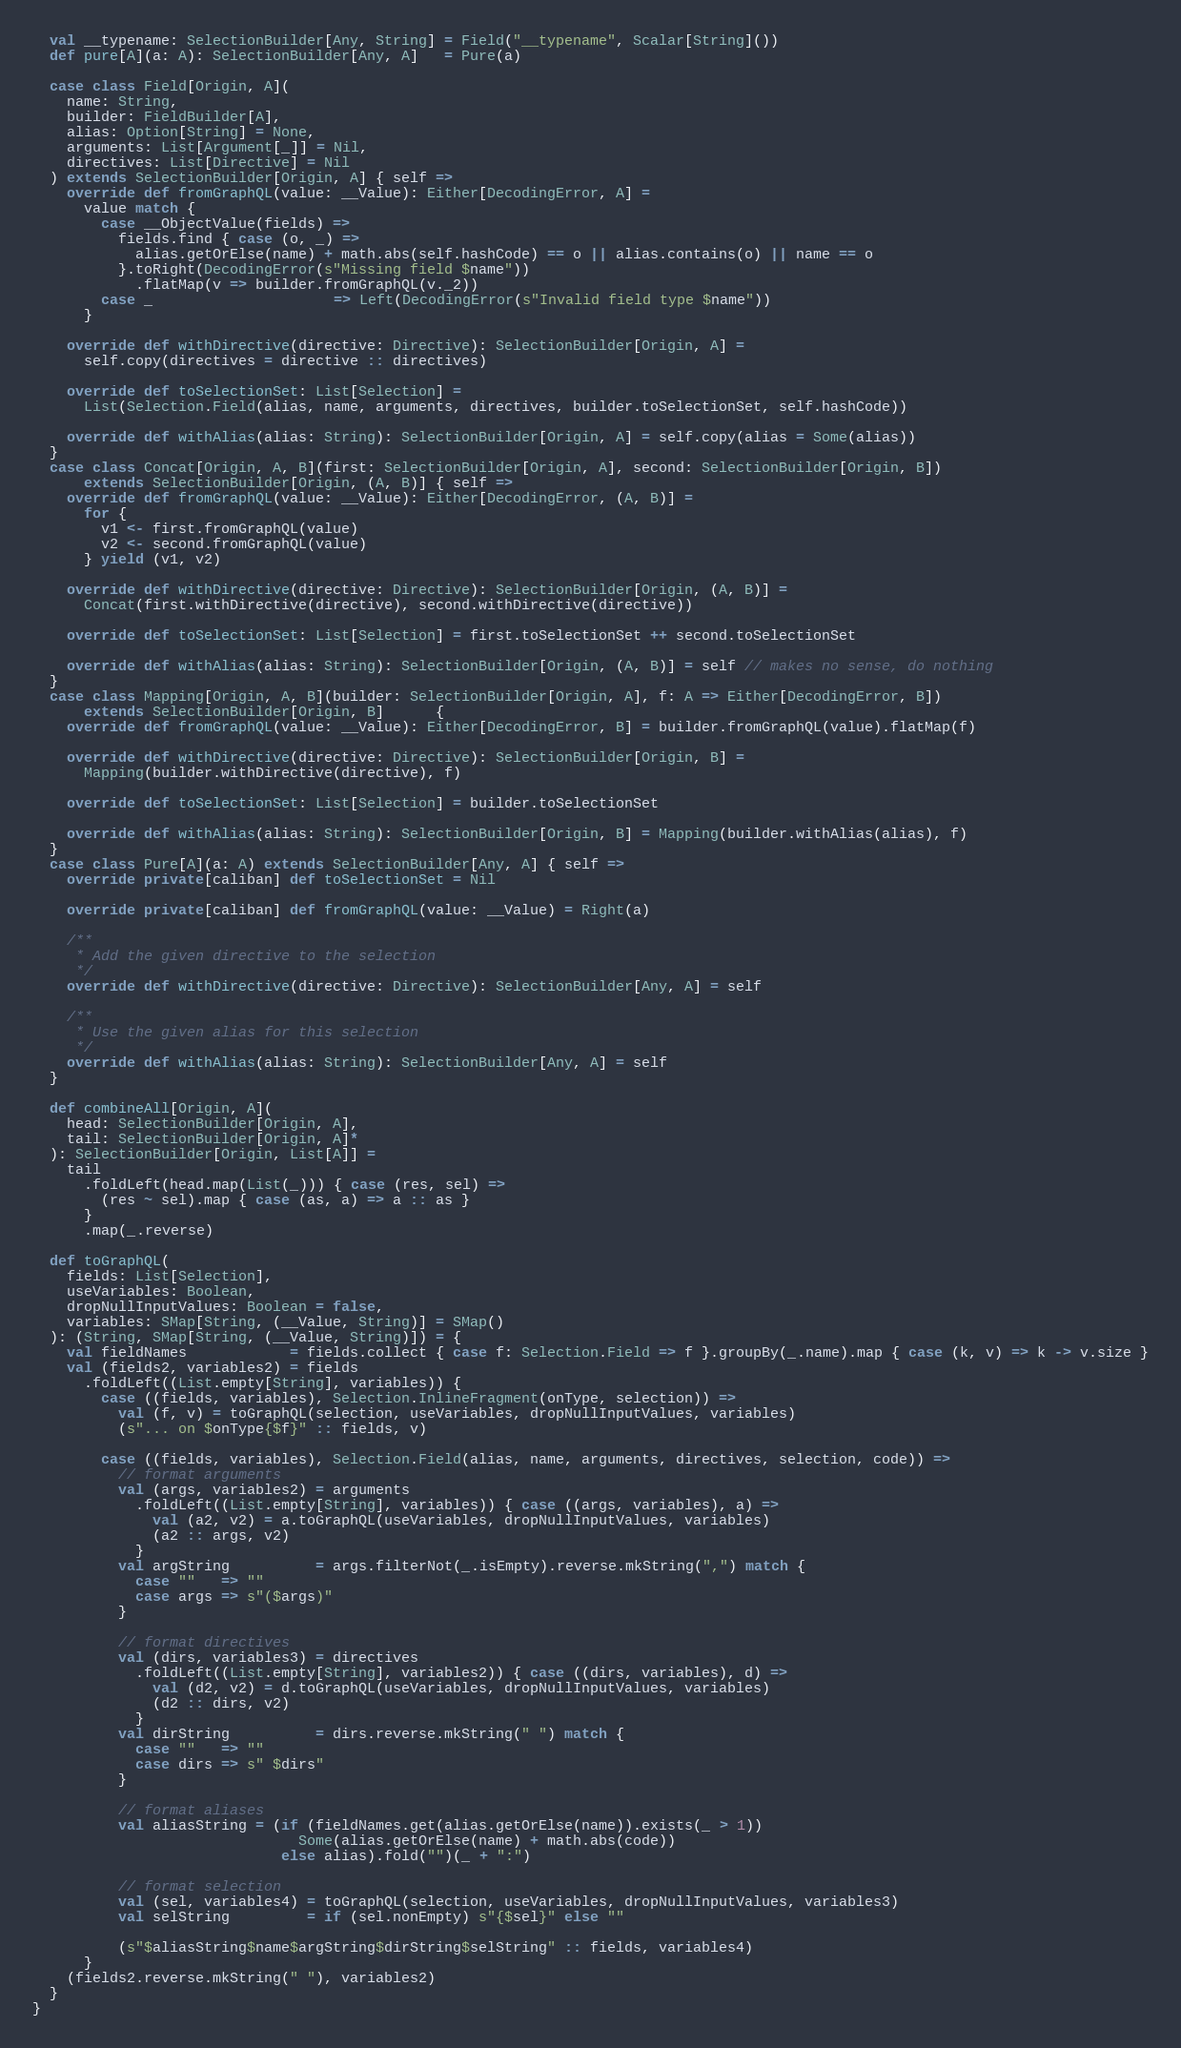<code> <loc_0><loc_0><loc_500><loc_500><_Scala_>
  val __typename: SelectionBuilder[Any, String] = Field("__typename", Scalar[String]())
  def pure[A](a: A): SelectionBuilder[Any, A]   = Pure(a)

  case class Field[Origin, A](
    name: String,
    builder: FieldBuilder[A],
    alias: Option[String] = None,
    arguments: List[Argument[_]] = Nil,
    directives: List[Directive] = Nil
  ) extends SelectionBuilder[Origin, A] { self =>
    override def fromGraphQL(value: __Value): Either[DecodingError, A] =
      value match {
        case __ObjectValue(fields) =>
          fields.find { case (o, _) =>
            alias.getOrElse(name) + math.abs(self.hashCode) == o || alias.contains(o) || name == o
          }.toRight(DecodingError(s"Missing field $name"))
            .flatMap(v => builder.fromGraphQL(v._2))
        case _                     => Left(DecodingError(s"Invalid field type $name"))
      }

    override def withDirective(directive: Directive): SelectionBuilder[Origin, A] =
      self.copy(directives = directive :: directives)

    override def toSelectionSet: List[Selection] =
      List(Selection.Field(alias, name, arguments, directives, builder.toSelectionSet, self.hashCode))

    override def withAlias(alias: String): SelectionBuilder[Origin, A] = self.copy(alias = Some(alias))
  }
  case class Concat[Origin, A, B](first: SelectionBuilder[Origin, A], second: SelectionBuilder[Origin, B])
      extends SelectionBuilder[Origin, (A, B)] { self =>
    override def fromGraphQL(value: __Value): Either[DecodingError, (A, B)] =
      for {
        v1 <- first.fromGraphQL(value)
        v2 <- second.fromGraphQL(value)
      } yield (v1, v2)

    override def withDirective(directive: Directive): SelectionBuilder[Origin, (A, B)] =
      Concat(first.withDirective(directive), second.withDirective(directive))

    override def toSelectionSet: List[Selection] = first.toSelectionSet ++ second.toSelectionSet

    override def withAlias(alias: String): SelectionBuilder[Origin, (A, B)] = self // makes no sense, do nothing
  }
  case class Mapping[Origin, A, B](builder: SelectionBuilder[Origin, A], f: A => Either[DecodingError, B])
      extends SelectionBuilder[Origin, B]      {
    override def fromGraphQL(value: __Value): Either[DecodingError, B] = builder.fromGraphQL(value).flatMap(f)

    override def withDirective(directive: Directive): SelectionBuilder[Origin, B] =
      Mapping(builder.withDirective(directive), f)

    override def toSelectionSet: List[Selection] = builder.toSelectionSet

    override def withAlias(alias: String): SelectionBuilder[Origin, B] = Mapping(builder.withAlias(alias), f)
  }
  case class Pure[A](a: A) extends SelectionBuilder[Any, A] { self =>
    override private[caliban] def toSelectionSet = Nil

    override private[caliban] def fromGraphQL(value: __Value) = Right(a)

    /**
     * Add the given directive to the selection
     */
    override def withDirective(directive: Directive): SelectionBuilder[Any, A] = self

    /**
     * Use the given alias for this selection
     */
    override def withAlias(alias: String): SelectionBuilder[Any, A] = self
  }

  def combineAll[Origin, A](
    head: SelectionBuilder[Origin, A],
    tail: SelectionBuilder[Origin, A]*
  ): SelectionBuilder[Origin, List[A]] =
    tail
      .foldLeft(head.map(List(_))) { case (res, sel) =>
        (res ~ sel).map { case (as, a) => a :: as }
      }
      .map(_.reverse)

  def toGraphQL(
    fields: List[Selection],
    useVariables: Boolean,
    dropNullInputValues: Boolean = false,
    variables: SMap[String, (__Value, String)] = SMap()
  ): (String, SMap[String, (__Value, String)]) = {
    val fieldNames            = fields.collect { case f: Selection.Field => f }.groupBy(_.name).map { case (k, v) => k -> v.size }
    val (fields2, variables2) = fields
      .foldLeft((List.empty[String], variables)) {
        case ((fields, variables), Selection.InlineFragment(onType, selection)) =>
          val (f, v) = toGraphQL(selection, useVariables, dropNullInputValues, variables)
          (s"... on $onType{$f}" :: fields, v)

        case ((fields, variables), Selection.Field(alias, name, arguments, directives, selection, code)) =>
          // format arguments
          val (args, variables2) = arguments
            .foldLeft((List.empty[String], variables)) { case ((args, variables), a) =>
              val (a2, v2) = a.toGraphQL(useVariables, dropNullInputValues, variables)
              (a2 :: args, v2)
            }
          val argString          = args.filterNot(_.isEmpty).reverse.mkString(",") match {
            case ""   => ""
            case args => s"($args)"
          }

          // format directives
          val (dirs, variables3) = directives
            .foldLeft((List.empty[String], variables2)) { case ((dirs, variables), d) =>
              val (d2, v2) = d.toGraphQL(useVariables, dropNullInputValues, variables)
              (d2 :: dirs, v2)
            }
          val dirString          = dirs.reverse.mkString(" ") match {
            case ""   => ""
            case dirs => s" $dirs"
          }

          // format aliases
          val aliasString = (if (fieldNames.get(alias.getOrElse(name)).exists(_ > 1))
                               Some(alias.getOrElse(name) + math.abs(code))
                             else alias).fold("")(_ + ":")

          // format selection
          val (sel, variables4) = toGraphQL(selection, useVariables, dropNullInputValues, variables3)
          val selString         = if (sel.nonEmpty) s"{$sel}" else ""

          (s"$aliasString$name$argString$dirString$selString" :: fields, variables4)
      }
    (fields2.reverse.mkString(" "), variables2)
  }
}
</code> 